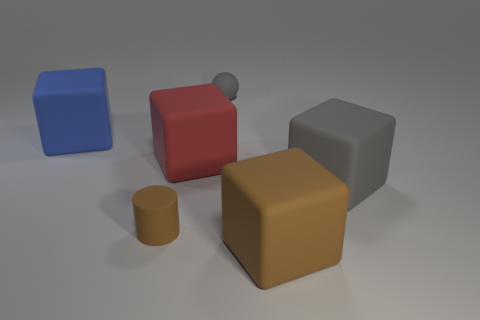Are there any red cubes made of the same material as the gray block?
Your response must be concise. Yes. There is a brown object that is the same size as the gray sphere; what material is it?
Keep it short and to the point. Rubber. There is a matte object that is in front of the red rubber block and left of the matte sphere; how big is it?
Keep it short and to the point. Small. There is a big object that is behind the brown rubber cylinder and in front of the red cube; what is its color?
Provide a succinct answer. Gray. Is the number of big blue cubes that are in front of the big red matte object less than the number of large gray rubber blocks left of the gray rubber block?
Your response must be concise. No. What number of other things are the same shape as the red rubber object?
Offer a terse response. 3. The gray ball that is made of the same material as the tiny cylinder is what size?
Your answer should be compact. Small. The tiny rubber object that is in front of the tiny matte thing that is behind the blue matte block is what color?
Offer a terse response. Brown. There is a big brown rubber object; does it have the same shape as the big object on the left side of the big red rubber cube?
Make the answer very short. Yes. What number of green spheres are the same size as the red block?
Your answer should be compact. 0. 